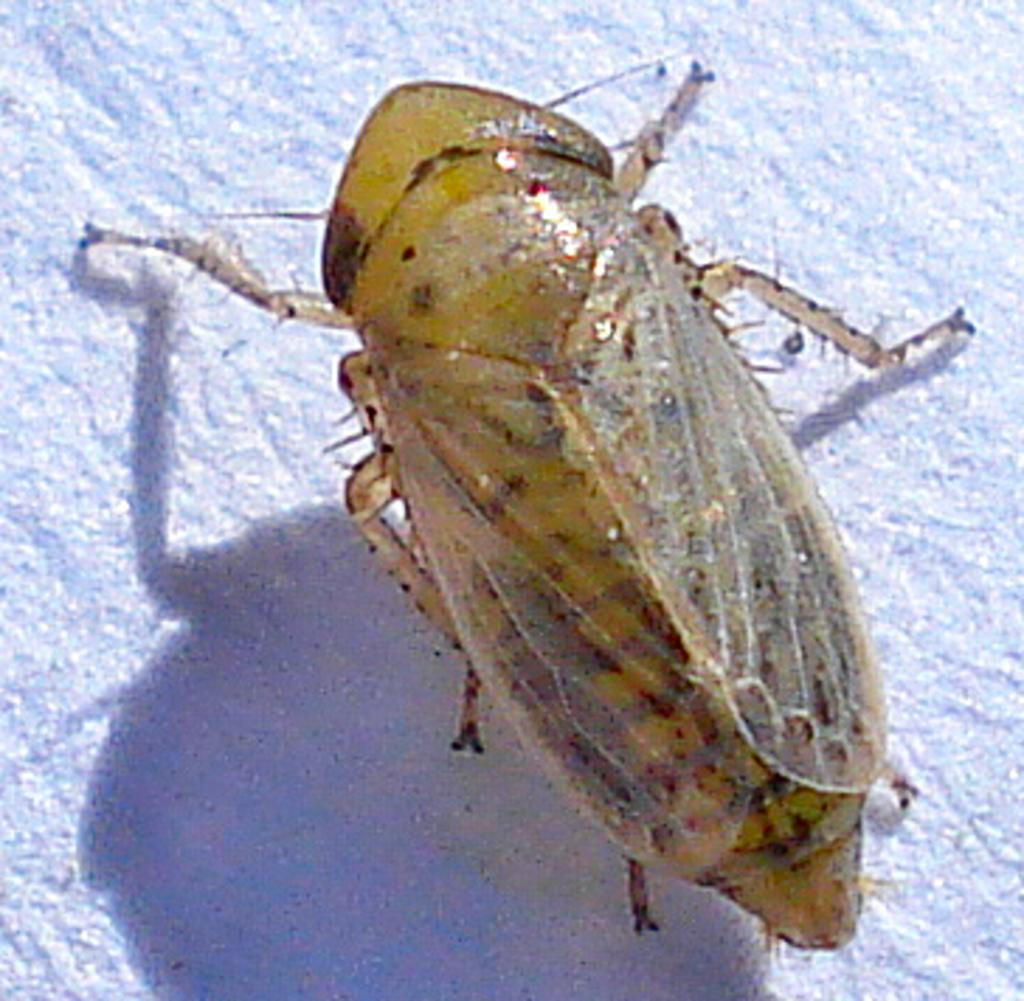What type of creature can be seen in the image? There is an insect in the image. Where is the insect located in the image? The insect is on a surface. What type of stamp can be seen on the insect in the image? There is no stamp present on the insect in the image. How does the insect use the rifle in the image? There is no rifle present in the image, and insects do not use rifles. 